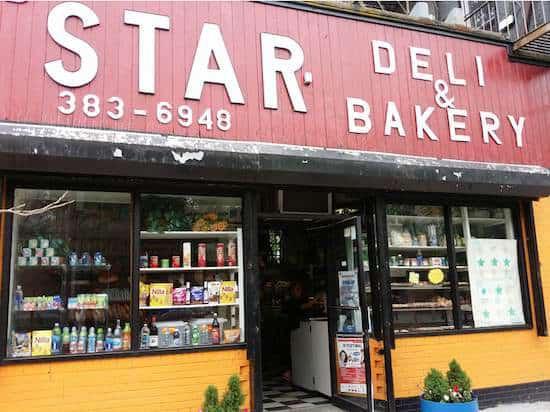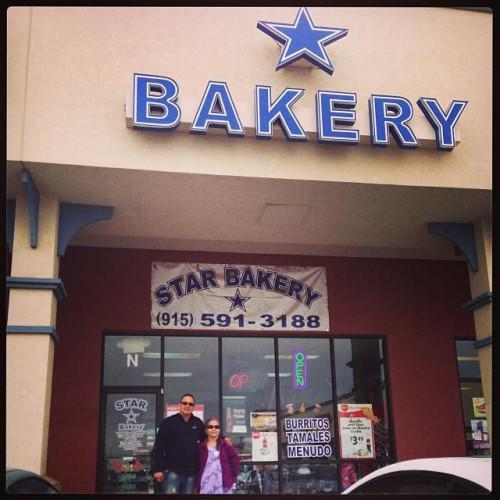The first image is the image on the left, the second image is the image on the right. Assess this claim about the two images: "An exterior view shows a star shape near lettering above a square opening in the right image.". Correct or not? Answer yes or no. Yes. The first image is the image on the left, the second image is the image on the right. Assess this claim about the two images: "there is a bakery with a star shape on their sign and black framed windows". Correct or not? Answer yes or no. Yes. 